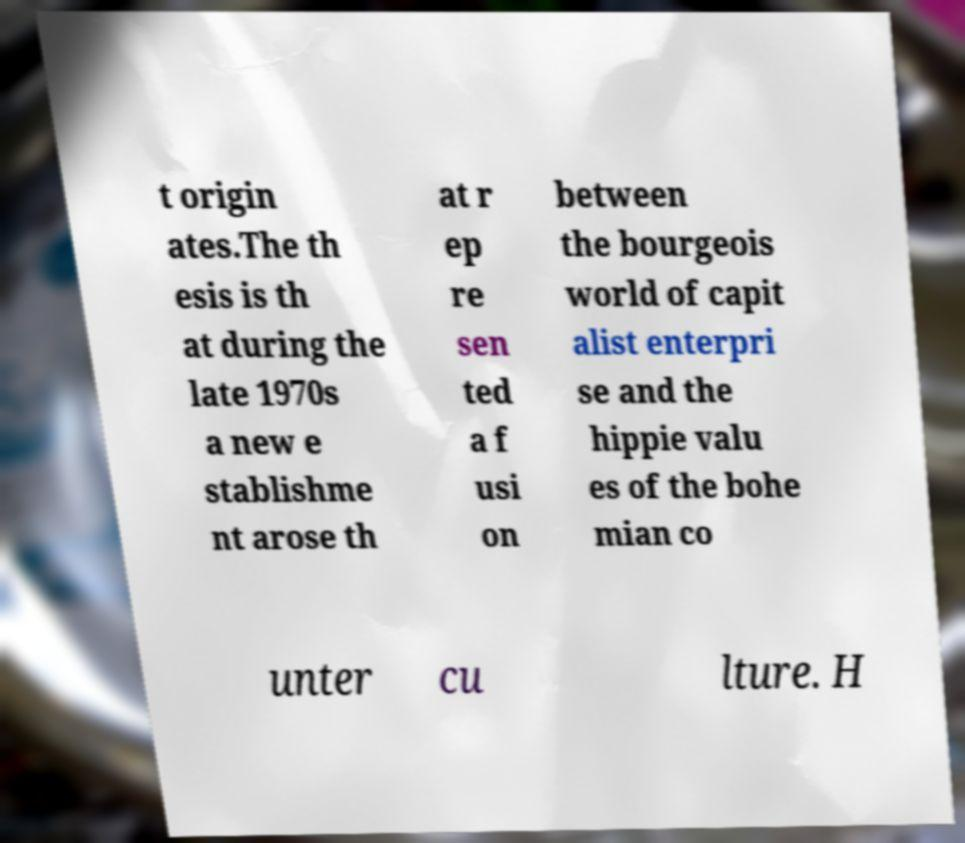I need the written content from this picture converted into text. Can you do that? t origin ates.The th esis is th at during the late 1970s a new e stablishme nt arose th at r ep re sen ted a f usi on between the bourgeois world of capit alist enterpri se and the hippie valu es of the bohe mian co unter cu lture. H 